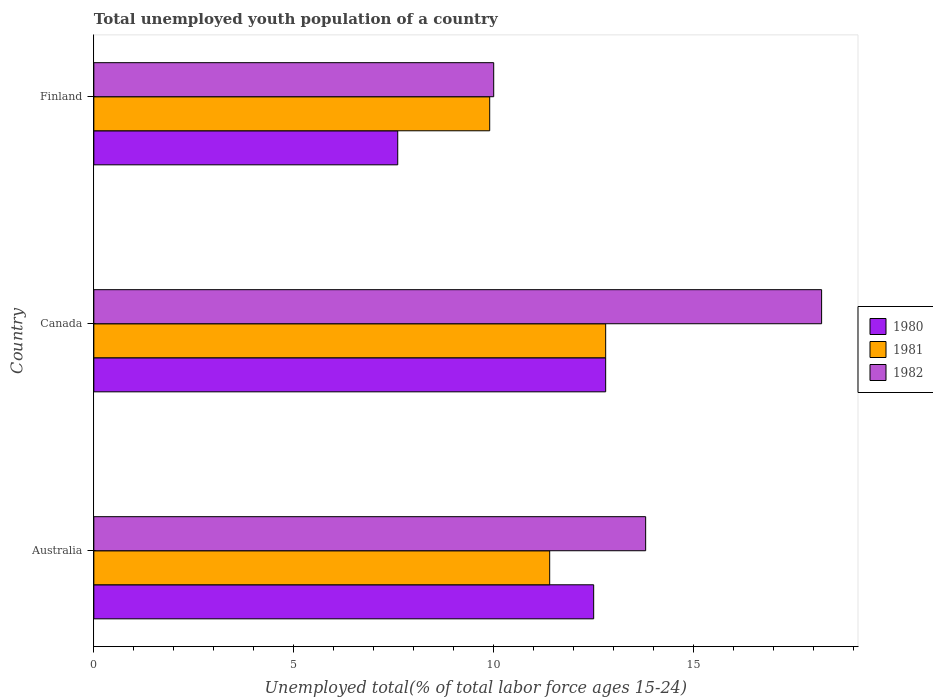How many groups of bars are there?
Your answer should be very brief. 3. Are the number of bars on each tick of the Y-axis equal?
Keep it short and to the point. Yes. How many bars are there on the 2nd tick from the top?
Provide a succinct answer. 3. What is the percentage of total unemployed youth population of a country in 1981 in Australia?
Give a very brief answer. 11.4. Across all countries, what is the maximum percentage of total unemployed youth population of a country in 1981?
Provide a succinct answer. 12.8. Across all countries, what is the minimum percentage of total unemployed youth population of a country in 1980?
Your response must be concise. 7.6. In which country was the percentage of total unemployed youth population of a country in 1981 maximum?
Make the answer very short. Canada. In which country was the percentage of total unemployed youth population of a country in 1981 minimum?
Offer a very short reply. Finland. What is the total percentage of total unemployed youth population of a country in 1981 in the graph?
Make the answer very short. 34.1. What is the difference between the percentage of total unemployed youth population of a country in 1982 in Canada and that in Finland?
Provide a succinct answer. 8.2. What is the difference between the percentage of total unemployed youth population of a country in 1980 in Canada and the percentage of total unemployed youth population of a country in 1982 in Australia?
Make the answer very short. -1. What is the average percentage of total unemployed youth population of a country in 1982 per country?
Offer a very short reply. 14. What is the difference between the percentage of total unemployed youth population of a country in 1980 and percentage of total unemployed youth population of a country in 1982 in Australia?
Ensure brevity in your answer.  -1.3. What is the ratio of the percentage of total unemployed youth population of a country in 1981 in Australia to that in Finland?
Your response must be concise. 1.15. Is the percentage of total unemployed youth population of a country in 1982 in Australia less than that in Canada?
Ensure brevity in your answer.  Yes. Is the difference between the percentage of total unemployed youth population of a country in 1980 in Australia and Canada greater than the difference between the percentage of total unemployed youth population of a country in 1982 in Australia and Canada?
Offer a terse response. Yes. What is the difference between the highest and the second highest percentage of total unemployed youth population of a country in 1982?
Make the answer very short. 4.4. What is the difference between the highest and the lowest percentage of total unemployed youth population of a country in 1982?
Offer a terse response. 8.2. Is the sum of the percentage of total unemployed youth population of a country in 1980 in Australia and Finland greater than the maximum percentage of total unemployed youth population of a country in 1981 across all countries?
Your answer should be compact. Yes. How many countries are there in the graph?
Your response must be concise. 3. What is the difference between two consecutive major ticks on the X-axis?
Give a very brief answer. 5. Does the graph contain any zero values?
Keep it short and to the point. No. Does the graph contain grids?
Provide a succinct answer. No. How many legend labels are there?
Provide a succinct answer. 3. What is the title of the graph?
Offer a terse response. Total unemployed youth population of a country. What is the label or title of the X-axis?
Offer a very short reply. Unemployed total(% of total labor force ages 15-24). What is the label or title of the Y-axis?
Provide a short and direct response. Country. What is the Unemployed total(% of total labor force ages 15-24) of 1981 in Australia?
Your answer should be compact. 11.4. What is the Unemployed total(% of total labor force ages 15-24) in 1982 in Australia?
Your answer should be very brief. 13.8. What is the Unemployed total(% of total labor force ages 15-24) in 1980 in Canada?
Offer a very short reply. 12.8. What is the Unemployed total(% of total labor force ages 15-24) in 1981 in Canada?
Ensure brevity in your answer.  12.8. What is the Unemployed total(% of total labor force ages 15-24) in 1982 in Canada?
Give a very brief answer. 18.2. What is the Unemployed total(% of total labor force ages 15-24) of 1980 in Finland?
Provide a succinct answer. 7.6. What is the Unemployed total(% of total labor force ages 15-24) in 1981 in Finland?
Offer a terse response. 9.9. Across all countries, what is the maximum Unemployed total(% of total labor force ages 15-24) in 1980?
Your answer should be compact. 12.8. Across all countries, what is the maximum Unemployed total(% of total labor force ages 15-24) of 1981?
Provide a short and direct response. 12.8. Across all countries, what is the maximum Unemployed total(% of total labor force ages 15-24) in 1982?
Provide a succinct answer. 18.2. Across all countries, what is the minimum Unemployed total(% of total labor force ages 15-24) of 1980?
Ensure brevity in your answer.  7.6. Across all countries, what is the minimum Unemployed total(% of total labor force ages 15-24) of 1981?
Your answer should be compact. 9.9. Across all countries, what is the minimum Unemployed total(% of total labor force ages 15-24) of 1982?
Provide a short and direct response. 10. What is the total Unemployed total(% of total labor force ages 15-24) in 1980 in the graph?
Your answer should be very brief. 32.9. What is the total Unemployed total(% of total labor force ages 15-24) of 1981 in the graph?
Give a very brief answer. 34.1. What is the difference between the Unemployed total(% of total labor force ages 15-24) of 1980 in Australia and that in Canada?
Offer a terse response. -0.3. What is the difference between the Unemployed total(% of total labor force ages 15-24) in 1980 in Australia and that in Finland?
Give a very brief answer. 4.9. What is the difference between the Unemployed total(% of total labor force ages 15-24) of 1982 in Canada and that in Finland?
Ensure brevity in your answer.  8.2. What is the difference between the Unemployed total(% of total labor force ages 15-24) in 1980 in Australia and the Unemployed total(% of total labor force ages 15-24) in 1981 in Canada?
Provide a short and direct response. -0.3. What is the difference between the Unemployed total(% of total labor force ages 15-24) of 1980 in Australia and the Unemployed total(% of total labor force ages 15-24) of 1982 in Canada?
Your answer should be very brief. -5.7. What is the difference between the Unemployed total(% of total labor force ages 15-24) in 1981 in Australia and the Unemployed total(% of total labor force ages 15-24) in 1982 in Canada?
Provide a short and direct response. -6.8. What is the difference between the Unemployed total(% of total labor force ages 15-24) of 1980 in Australia and the Unemployed total(% of total labor force ages 15-24) of 1981 in Finland?
Your response must be concise. 2.6. What is the difference between the Unemployed total(% of total labor force ages 15-24) of 1980 in Canada and the Unemployed total(% of total labor force ages 15-24) of 1981 in Finland?
Your response must be concise. 2.9. What is the difference between the Unemployed total(% of total labor force ages 15-24) of 1980 in Canada and the Unemployed total(% of total labor force ages 15-24) of 1982 in Finland?
Your response must be concise. 2.8. What is the difference between the Unemployed total(% of total labor force ages 15-24) of 1981 in Canada and the Unemployed total(% of total labor force ages 15-24) of 1982 in Finland?
Provide a succinct answer. 2.8. What is the average Unemployed total(% of total labor force ages 15-24) in 1980 per country?
Your answer should be very brief. 10.97. What is the average Unemployed total(% of total labor force ages 15-24) of 1981 per country?
Ensure brevity in your answer.  11.37. What is the difference between the Unemployed total(% of total labor force ages 15-24) in 1980 and Unemployed total(% of total labor force ages 15-24) in 1981 in Australia?
Offer a very short reply. 1.1. What is the difference between the Unemployed total(% of total labor force ages 15-24) of 1981 and Unemployed total(% of total labor force ages 15-24) of 1982 in Canada?
Provide a succinct answer. -5.4. What is the difference between the Unemployed total(% of total labor force ages 15-24) in 1980 and Unemployed total(% of total labor force ages 15-24) in 1981 in Finland?
Offer a terse response. -2.3. What is the difference between the Unemployed total(% of total labor force ages 15-24) in 1980 and Unemployed total(% of total labor force ages 15-24) in 1982 in Finland?
Your response must be concise. -2.4. What is the difference between the Unemployed total(% of total labor force ages 15-24) in 1981 and Unemployed total(% of total labor force ages 15-24) in 1982 in Finland?
Ensure brevity in your answer.  -0.1. What is the ratio of the Unemployed total(% of total labor force ages 15-24) in 1980 in Australia to that in Canada?
Ensure brevity in your answer.  0.98. What is the ratio of the Unemployed total(% of total labor force ages 15-24) of 1981 in Australia to that in Canada?
Ensure brevity in your answer.  0.89. What is the ratio of the Unemployed total(% of total labor force ages 15-24) of 1982 in Australia to that in Canada?
Ensure brevity in your answer.  0.76. What is the ratio of the Unemployed total(% of total labor force ages 15-24) of 1980 in Australia to that in Finland?
Provide a succinct answer. 1.64. What is the ratio of the Unemployed total(% of total labor force ages 15-24) of 1981 in Australia to that in Finland?
Give a very brief answer. 1.15. What is the ratio of the Unemployed total(% of total labor force ages 15-24) in 1982 in Australia to that in Finland?
Provide a succinct answer. 1.38. What is the ratio of the Unemployed total(% of total labor force ages 15-24) of 1980 in Canada to that in Finland?
Make the answer very short. 1.68. What is the ratio of the Unemployed total(% of total labor force ages 15-24) in 1981 in Canada to that in Finland?
Give a very brief answer. 1.29. What is the ratio of the Unemployed total(% of total labor force ages 15-24) of 1982 in Canada to that in Finland?
Keep it short and to the point. 1.82. What is the difference between the highest and the second highest Unemployed total(% of total labor force ages 15-24) in 1980?
Provide a short and direct response. 0.3. What is the difference between the highest and the second highest Unemployed total(% of total labor force ages 15-24) in 1981?
Ensure brevity in your answer.  1.4. What is the difference between the highest and the lowest Unemployed total(% of total labor force ages 15-24) of 1980?
Provide a short and direct response. 5.2. What is the difference between the highest and the lowest Unemployed total(% of total labor force ages 15-24) of 1981?
Provide a succinct answer. 2.9. 